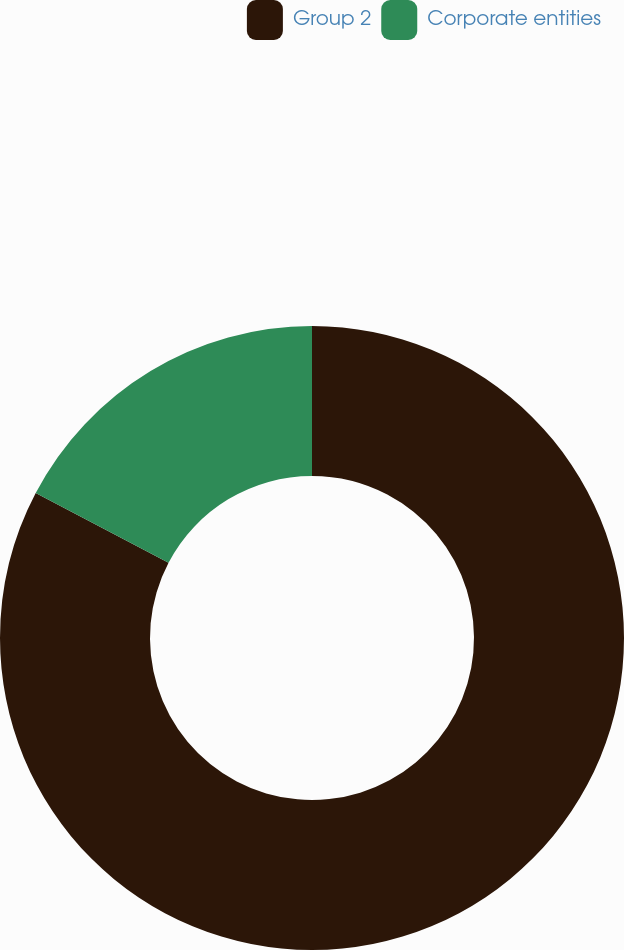Convert chart to OTSL. <chart><loc_0><loc_0><loc_500><loc_500><pie_chart><fcel>Group 2<fcel>Corporate entities<nl><fcel>82.69%<fcel>17.31%<nl></chart> 